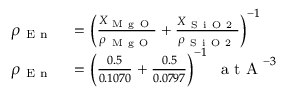Convert formula to latex. <formula><loc_0><loc_0><loc_500><loc_500>\begin{array} { r l } { \rho _ { E n } } & = \left ( \frac { X _ { M g O } } { \rho _ { M g O } } + \frac { X _ { S i O 2 } } { \rho _ { S i O 2 } } \right ) ^ { - 1 } } \\ { \rho _ { E n } } & = \left ( \frac { 0 . 5 } { 0 . 1 0 7 0 } + \frac { 0 . 5 } { 0 . 0 7 9 7 } \right ) ^ { - 1 } \, a t A ^ { - 3 } } \end{array}</formula> 